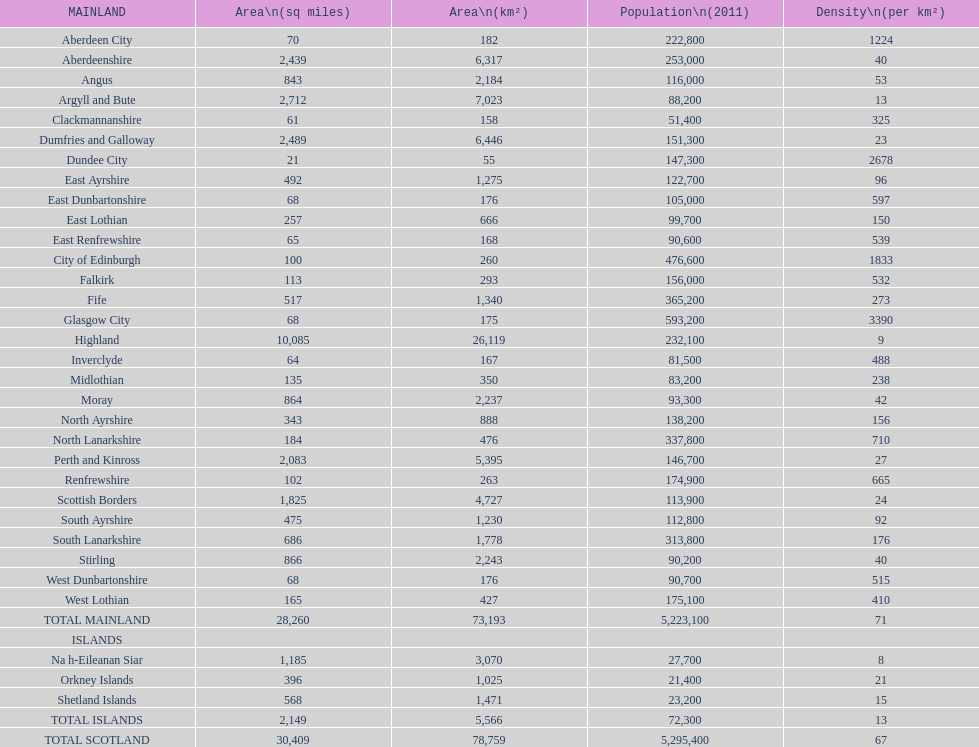What is the typical population density in cities located on the mainland? 71. 